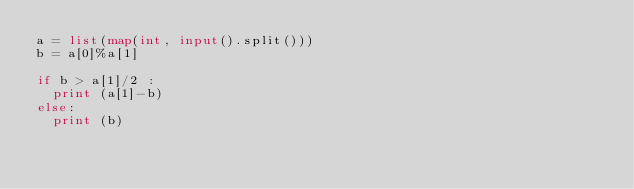Convert code to text. <code><loc_0><loc_0><loc_500><loc_500><_Python_>a = list(map(int, input().split()))
b = a[0]%a[1]

if b > a[1]/2 :
  print (a[1]-b)
else:
  print (b)</code> 